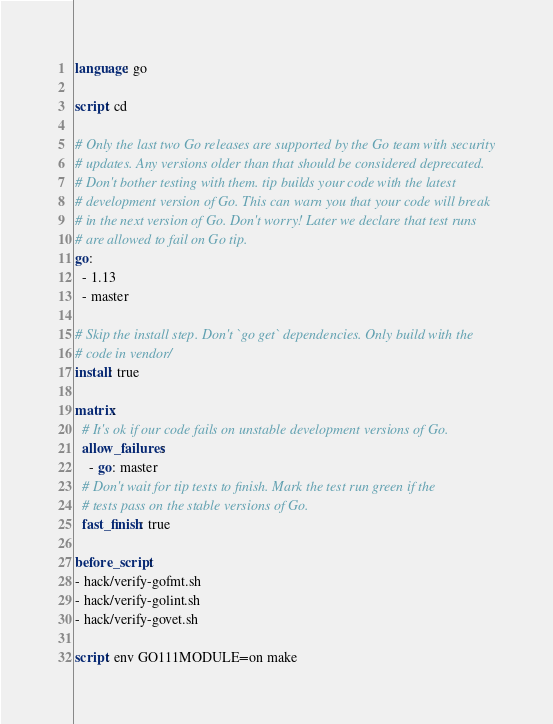<code> <loc_0><loc_0><loc_500><loc_500><_YAML_>language: go

script: cd 

# Only the last two Go releases are supported by the Go team with security
# updates. Any versions older than that should be considered deprecated.
# Don't bother testing with them. tip builds your code with the latest
# development version of Go. This can warn you that your code will break
# in the next version of Go. Don't worry! Later we declare that test runs
# are allowed to fail on Go tip.
go:
  - 1.13
  - master 

# Skip the install step. Don't `go get` dependencies. Only build with the
# code in vendor/
install: true

matrix:
  # It's ok if our code fails on unstable development versions of Go.
  allow_failures:
    - go: master
  # Don't wait for tip tests to finish. Mark the test run green if the
  # tests pass on the stable versions of Go.
  fast_finish: true
  
before_script:
- hack/verify-gofmt.sh
- hack/verify-golint.sh
- hack/verify-govet.sh

script: env GO111MODULE=on make
</code> 